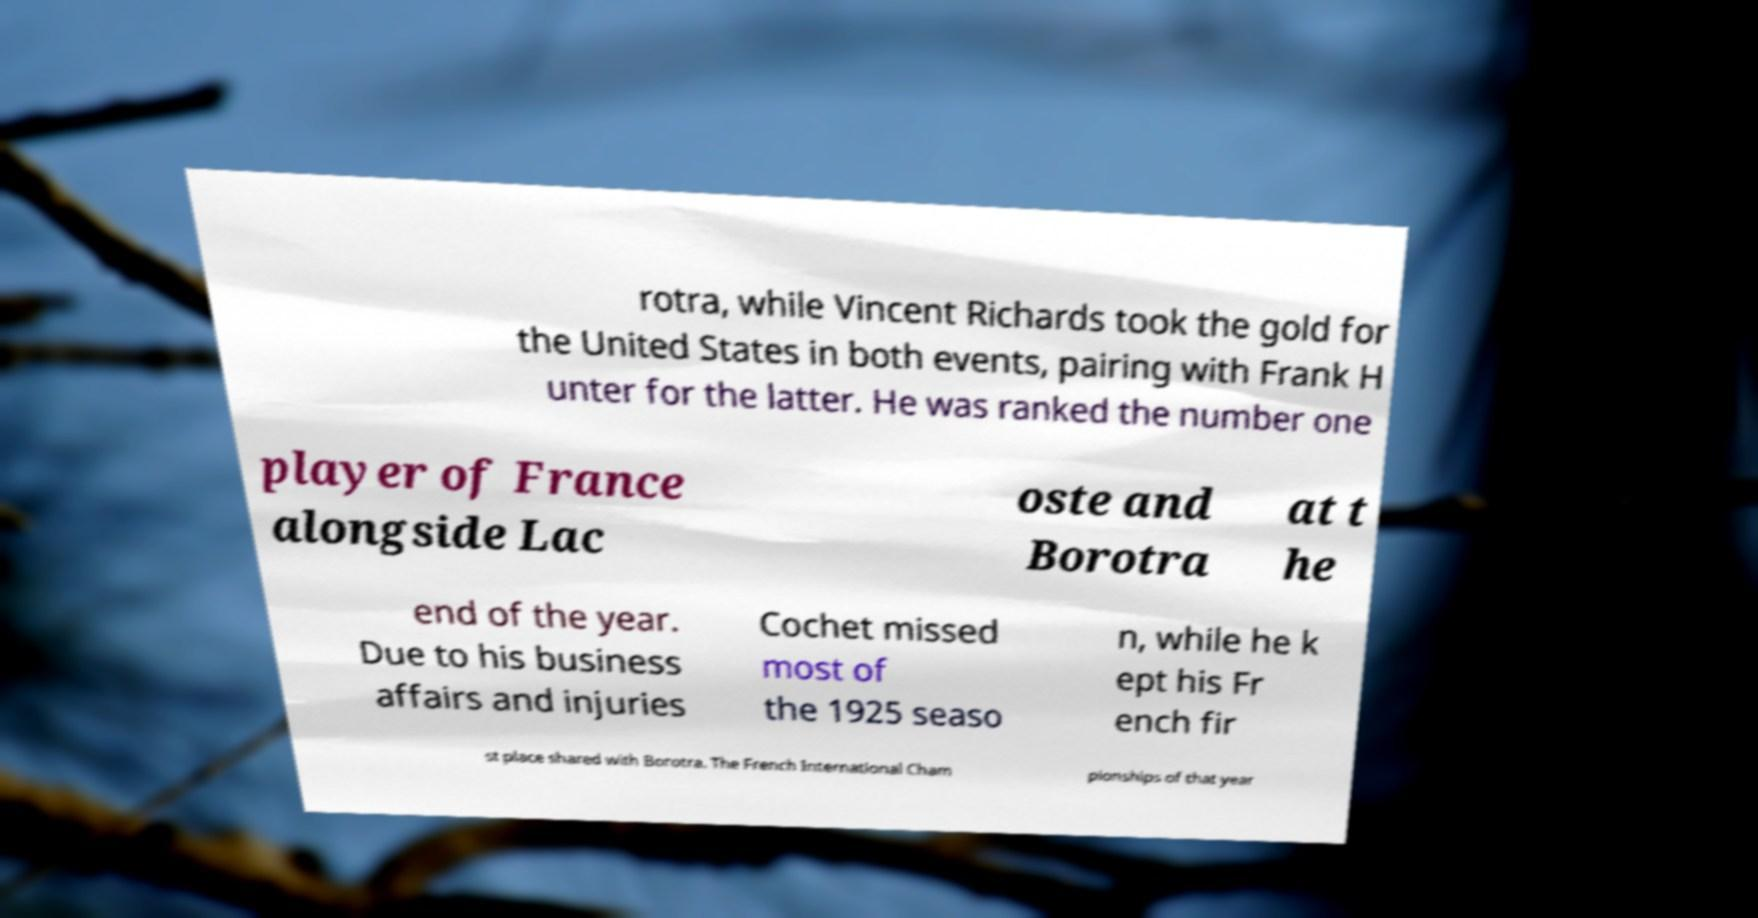For documentation purposes, I need the text within this image transcribed. Could you provide that? rotra, while Vincent Richards took the gold for the United States in both events, pairing with Frank H unter for the latter. He was ranked the number one player of France alongside Lac oste and Borotra at t he end of the year. Due to his business affairs and injuries Cochet missed most of the 1925 seaso n, while he k ept his Fr ench fir st place shared with Borotra. The French International Cham pionships of that year 